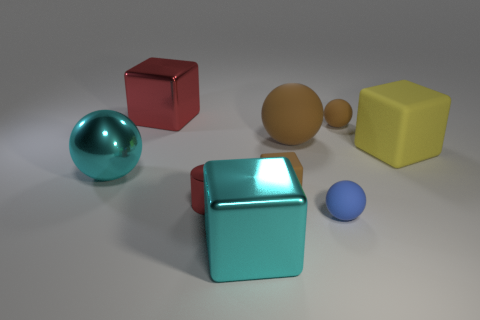What is the size of the other rubber ball that is the same color as the big matte sphere?
Your answer should be compact. Small. What number of blocks have the same color as the large matte sphere?
Your answer should be very brief. 1. There is a large cyan metallic object behind the tiny blue ball; what is its shape?
Make the answer very short. Sphere. There is a shiny sphere that is the same size as the yellow thing; what color is it?
Ensure brevity in your answer.  Cyan. Does the red thing that is behind the tiny rubber block have the same material as the tiny red cylinder?
Your answer should be compact. Yes. There is a block that is on the left side of the small brown cube and behind the large cyan metallic block; what size is it?
Provide a short and direct response. Large. There is a sphere in front of the tiny red cylinder; how big is it?
Your response must be concise. Small. There is a small thing that is the same color as the small block; what is its shape?
Provide a succinct answer. Sphere. The cyan shiny object that is right of the big cyan object that is behind the thing in front of the small blue sphere is what shape?
Keep it short and to the point. Cube. What number of other objects are the same shape as the large yellow rubber object?
Offer a very short reply. 3. 